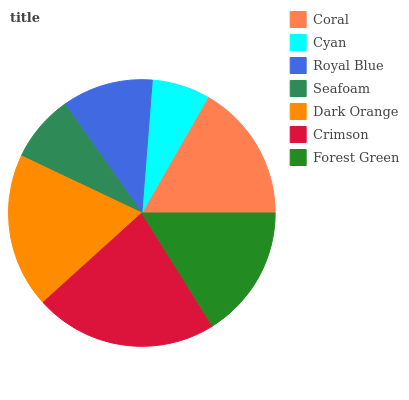Is Cyan the minimum?
Answer yes or no. Yes. Is Crimson the maximum?
Answer yes or no. Yes. Is Royal Blue the minimum?
Answer yes or no. No. Is Royal Blue the maximum?
Answer yes or no. No. Is Royal Blue greater than Cyan?
Answer yes or no. Yes. Is Cyan less than Royal Blue?
Answer yes or no. Yes. Is Cyan greater than Royal Blue?
Answer yes or no. No. Is Royal Blue less than Cyan?
Answer yes or no. No. Is Forest Green the high median?
Answer yes or no. Yes. Is Forest Green the low median?
Answer yes or no. Yes. Is Seafoam the high median?
Answer yes or no. No. Is Crimson the low median?
Answer yes or no. No. 